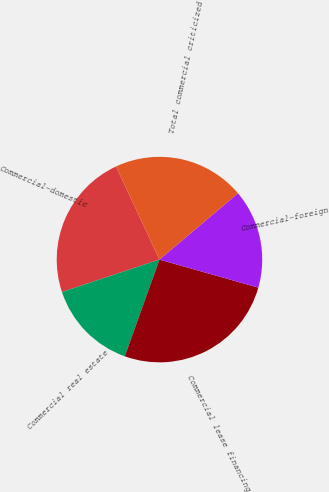Convert chart to OTSL. <chart><loc_0><loc_0><loc_500><loc_500><pie_chart><fcel>Commercial-domestic<fcel>Commercial real estate<fcel>Commercial lease financing<fcel>Commercial-foreign<fcel>Total commercial criticized<nl><fcel>23.17%<fcel>14.41%<fcel>26.08%<fcel>15.56%<fcel>20.78%<nl></chart> 